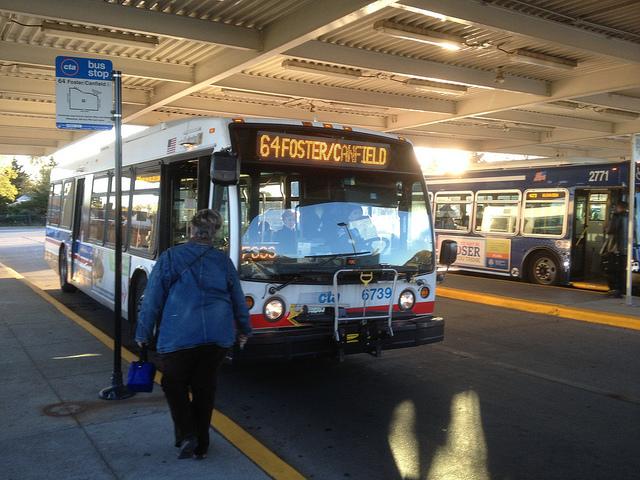What does the bus say on the front?
Keep it brief. 64 foster/canfield. Is this a foreign country?
Concise answer only. No. How many buses are there?
Keep it brief. 2. Are there any passengers visible on the bus?
Write a very short answer. Yes. 